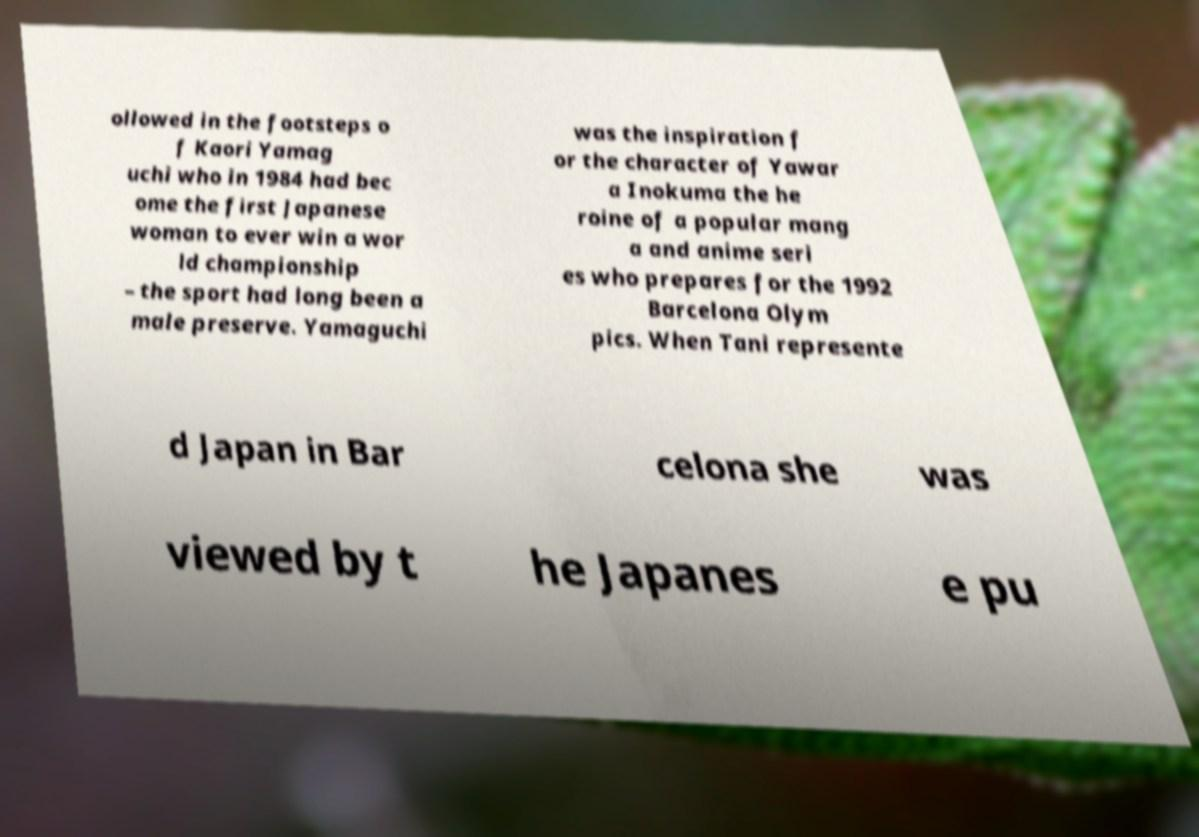Please read and relay the text visible in this image. What does it say? ollowed in the footsteps o f Kaori Yamag uchi who in 1984 had bec ome the first Japanese woman to ever win a wor ld championship – the sport had long been a male preserve. Yamaguchi was the inspiration f or the character of Yawar a Inokuma the he roine of a popular mang a and anime seri es who prepares for the 1992 Barcelona Olym pics. When Tani represente d Japan in Bar celona she was viewed by t he Japanes e pu 